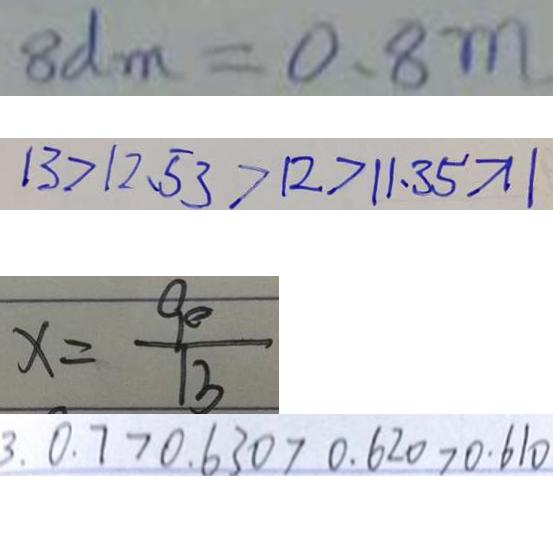<formula> <loc_0><loc_0><loc_500><loc_500>8 d m = 0 . 8 m 
 1 3 > 1 2 . 5 3 > 1 2 > 1 1 . 3 5 > 1 1 
 x = \frac { 9 0 } { 1 3 } 
 3 . 0 . 7 > 0 . 6 3 0 > 0 . 6 2 0 > 0 . 6 1 0</formula> 